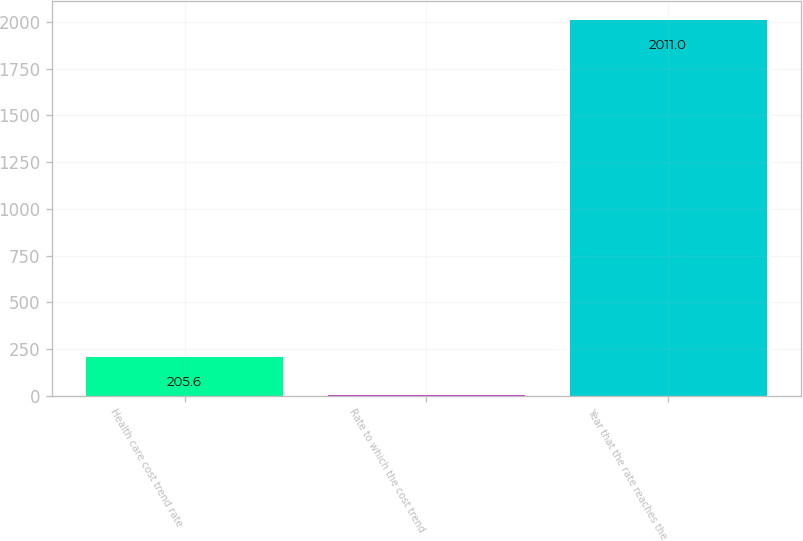Convert chart. <chart><loc_0><loc_0><loc_500><loc_500><bar_chart><fcel>Health care cost trend rate<fcel>Rate to which the cost trend<fcel>Year that the rate reaches the<nl><fcel>205.6<fcel>5<fcel>2011<nl></chart> 